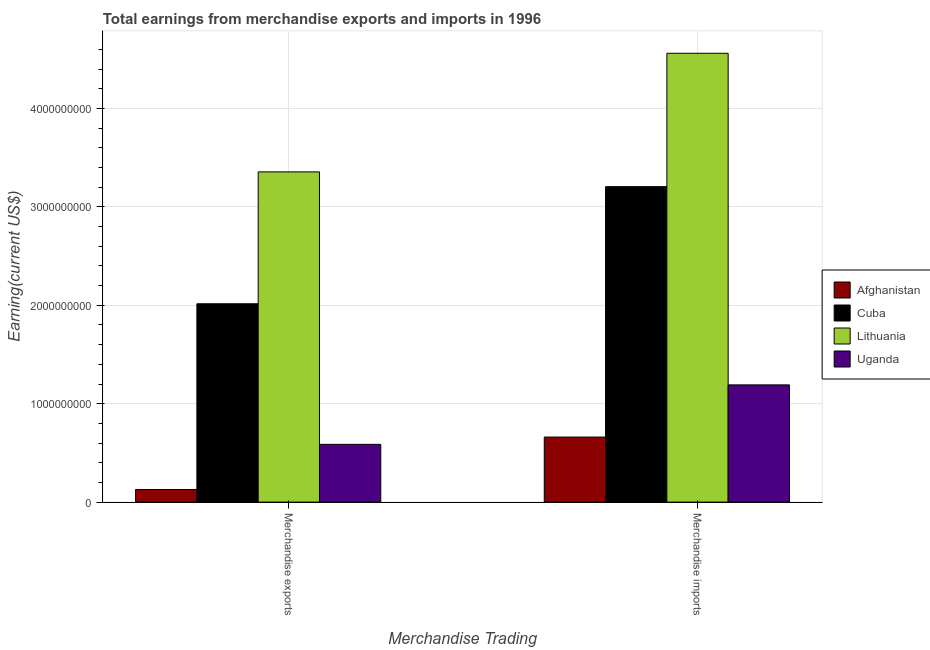How many groups of bars are there?
Provide a short and direct response. 2. How many bars are there on the 2nd tick from the left?
Your answer should be compact. 4. What is the label of the 1st group of bars from the left?
Offer a very short reply. Merchandise exports. What is the earnings from merchandise imports in Lithuania?
Offer a very short reply. 4.56e+09. Across all countries, what is the maximum earnings from merchandise imports?
Offer a terse response. 4.56e+09. Across all countries, what is the minimum earnings from merchandise exports?
Offer a very short reply. 1.28e+08. In which country was the earnings from merchandise imports maximum?
Your response must be concise. Lithuania. In which country was the earnings from merchandise exports minimum?
Offer a terse response. Afghanistan. What is the total earnings from merchandise imports in the graph?
Ensure brevity in your answer.  9.62e+09. What is the difference between the earnings from merchandise exports in Cuba and that in Lithuania?
Your answer should be compact. -1.34e+09. What is the difference between the earnings from merchandise imports in Afghanistan and the earnings from merchandise exports in Cuba?
Provide a succinct answer. -1.35e+09. What is the average earnings from merchandise exports per country?
Your answer should be compact. 1.52e+09. What is the difference between the earnings from merchandise imports and earnings from merchandise exports in Uganda?
Offer a very short reply. 6.04e+08. In how many countries, is the earnings from merchandise imports greater than 1200000000 US$?
Your response must be concise. 2. What is the ratio of the earnings from merchandise exports in Afghanistan to that in Cuba?
Ensure brevity in your answer.  0.06. In how many countries, is the earnings from merchandise exports greater than the average earnings from merchandise exports taken over all countries?
Offer a terse response. 2. What does the 2nd bar from the left in Merchandise exports represents?
Your answer should be very brief. Cuba. What does the 4th bar from the right in Merchandise exports represents?
Provide a short and direct response. Afghanistan. How many bars are there?
Provide a succinct answer. 8. Are all the bars in the graph horizontal?
Make the answer very short. No. What is the difference between two consecutive major ticks on the Y-axis?
Provide a short and direct response. 1.00e+09. Does the graph contain any zero values?
Give a very brief answer. No. Does the graph contain grids?
Give a very brief answer. Yes. Where does the legend appear in the graph?
Make the answer very short. Center right. What is the title of the graph?
Offer a terse response. Total earnings from merchandise exports and imports in 1996. What is the label or title of the X-axis?
Provide a short and direct response. Merchandise Trading. What is the label or title of the Y-axis?
Offer a terse response. Earning(current US$). What is the Earning(current US$) in Afghanistan in Merchandise exports?
Offer a terse response. 1.28e+08. What is the Earning(current US$) in Cuba in Merchandise exports?
Provide a succinct answer. 2.02e+09. What is the Earning(current US$) in Lithuania in Merchandise exports?
Make the answer very short. 3.36e+09. What is the Earning(current US$) of Uganda in Merchandise exports?
Give a very brief answer. 5.87e+08. What is the Earning(current US$) in Afghanistan in Merchandise imports?
Provide a short and direct response. 6.61e+08. What is the Earning(current US$) in Cuba in Merchandise imports?
Your answer should be very brief. 3.20e+09. What is the Earning(current US$) in Lithuania in Merchandise imports?
Offer a terse response. 4.56e+09. What is the Earning(current US$) in Uganda in Merchandise imports?
Offer a terse response. 1.19e+09. Across all Merchandise Trading, what is the maximum Earning(current US$) of Afghanistan?
Offer a very short reply. 6.61e+08. Across all Merchandise Trading, what is the maximum Earning(current US$) of Cuba?
Offer a very short reply. 3.20e+09. Across all Merchandise Trading, what is the maximum Earning(current US$) in Lithuania?
Your response must be concise. 4.56e+09. Across all Merchandise Trading, what is the maximum Earning(current US$) in Uganda?
Keep it short and to the point. 1.19e+09. Across all Merchandise Trading, what is the minimum Earning(current US$) of Afghanistan?
Provide a succinct answer. 1.28e+08. Across all Merchandise Trading, what is the minimum Earning(current US$) of Cuba?
Offer a very short reply. 2.02e+09. Across all Merchandise Trading, what is the minimum Earning(current US$) in Lithuania?
Offer a terse response. 3.36e+09. Across all Merchandise Trading, what is the minimum Earning(current US$) in Uganda?
Offer a very short reply. 5.87e+08. What is the total Earning(current US$) in Afghanistan in the graph?
Make the answer very short. 7.89e+08. What is the total Earning(current US$) in Cuba in the graph?
Keep it short and to the point. 5.22e+09. What is the total Earning(current US$) in Lithuania in the graph?
Ensure brevity in your answer.  7.92e+09. What is the total Earning(current US$) of Uganda in the graph?
Your answer should be compact. 1.78e+09. What is the difference between the Earning(current US$) in Afghanistan in Merchandise exports and that in Merchandise imports?
Offer a terse response. -5.33e+08. What is the difference between the Earning(current US$) in Cuba in Merchandise exports and that in Merchandise imports?
Provide a short and direct response. -1.19e+09. What is the difference between the Earning(current US$) of Lithuania in Merchandise exports and that in Merchandise imports?
Ensure brevity in your answer.  -1.20e+09. What is the difference between the Earning(current US$) of Uganda in Merchandise exports and that in Merchandise imports?
Make the answer very short. -6.04e+08. What is the difference between the Earning(current US$) of Afghanistan in Merchandise exports and the Earning(current US$) of Cuba in Merchandise imports?
Keep it short and to the point. -3.08e+09. What is the difference between the Earning(current US$) in Afghanistan in Merchandise exports and the Earning(current US$) in Lithuania in Merchandise imports?
Your answer should be very brief. -4.43e+09. What is the difference between the Earning(current US$) of Afghanistan in Merchandise exports and the Earning(current US$) of Uganda in Merchandise imports?
Offer a terse response. -1.06e+09. What is the difference between the Earning(current US$) of Cuba in Merchandise exports and the Earning(current US$) of Lithuania in Merchandise imports?
Give a very brief answer. -2.54e+09. What is the difference between the Earning(current US$) of Cuba in Merchandise exports and the Earning(current US$) of Uganda in Merchandise imports?
Give a very brief answer. 8.24e+08. What is the difference between the Earning(current US$) of Lithuania in Merchandise exports and the Earning(current US$) of Uganda in Merchandise imports?
Make the answer very short. 2.16e+09. What is the average Earning(current US$) in Afghanistan per Merchandise Trading?
Your answer should be compact. 3.95e+08. What is the average Earning(current US$) in Cuba per Merchandise Trading?
Keep it short and to the point. 2.61e+09. What is the average Earning(current US$) of Lithuania per Merchandise Trading?
Provide a succinct answer. 3.96e+09. What is the average Earning(current US$) of Uganda per Merchandise Trading?
Provide a succinct answer. 8.89e+08. What is the difference between the Earning(current US$) of Afghanistan and Earning(current US$) of Cuba in Merchandise exports?
Provide a short and direct response. -1.89e+09. What is the difference between the Earning(current US$) of Afghanistan and Earning(current US$) of Lithuania in Merchandise exports?
Give a very brief answer. -3.23e+09. What is the difference between the Earning(current US$) in Afghanistan and Earning(current US$) in Uganda in Merchandise exports?
Your answer should be compact. -4.59e+08. What is the difference between the Earning(current US$) in Cuba and Earning(current US$) in Lithuania in Merchandise exports?
Your response must be concise. -1.34e+09. What is the difference between the Earning(current US$) of Cuba and Earning(current US$) of Uganda in Merchandise exports?
Your response must be concise. 1.43e+09. What is the difference between the Earning(current US$) of Lithuania and Earning(current US$) of Uganda in Merchandise exports?
Make the answer very short. 2.77e+09. What is the difference between the Earning(current US$) in Afghanistan and Earning(current US$) in Cuba in Merchandise imports?
Offer a terse response. -2.54e+09. What is the difference between the Earning(current US$) in Afghanistan and Earning(current US$) in Lithuania in Merchandise imports?
Ensure brevity in your answer.  -3.90e+09. What is the difference between the Earning(current US$) of Afghanistan and Earning(current US$) of Uganda in Merchandise imports?
Ensure brevity in your answer.  -5.30e+08. What is the difference between the Earning(current US$) of Cuba and Earning(current US$) of Lithuania in Merchandise imports?
Give a very brief answer. -1.36e+09. What is the difference between the Earning(current US$) of Cuba and Earning(current US$) of Uganda in Merchandise imports?
Offer a very short reply. 2.01e+09. What is the difference between the Earning(current US$) of Lithuania and Earning(current US$) of Uganda in Merchandise imports?
Offer a very short reply. 3.37e+09. What is the ratio of the Earning(current US$) of Afghanistan in Merchandise exports to that in Merchandise imports?
Make the answer very short. 0.19. What is the ratio of the Earning(current US$) of Cuba in Merchandise exports to that in Merchandise imports?
Provide a succinct answer. 0.63. What is the ratio of the Earning(current US$) in Lithuania in Merchandise exports to that in Merchandise imports?
Give a very brief answer. 0.74. What is the ratio of the Earning(current US$) in Uganda in Merchandise exports to that in Merchandise imports?
Give a very brief answer. 0.49. What is the difference between the highest and the second highest Earning(current US$) of Afghanistan?
Give a very brief answer. 5.33e+08. What is the difference between the highest and the second highest Earning(current US$) in Cuba?
Provide a succinct answer. 1.19e+09. What is the difference between the highest and the second highest Earning(current US$) of Lithuania?
Your answer should be compact. 1.20e+09. What is the difference between the highest and the second highest Earning(current US$) of Uganda?
Give a very brief answer. 6.04e+08. What is the difference between the highest and the lowest Earning(current US$) of Afghanistan?
Provide a succinct answer. 5.33e+08. What is the difference between the highest and the lowest Earning(current US$) of Cuba?
Offer a very short reply. 1.19e+09. What is the difference between the highest and the lowest Earning(current US$) in Lithuania?
Ensure brevity in your answer.  1.20e+09. What is the difference between the highest and the lowest Earning(current US$) of Uganda?
Provide a short and direct response. 6.04e+08. 